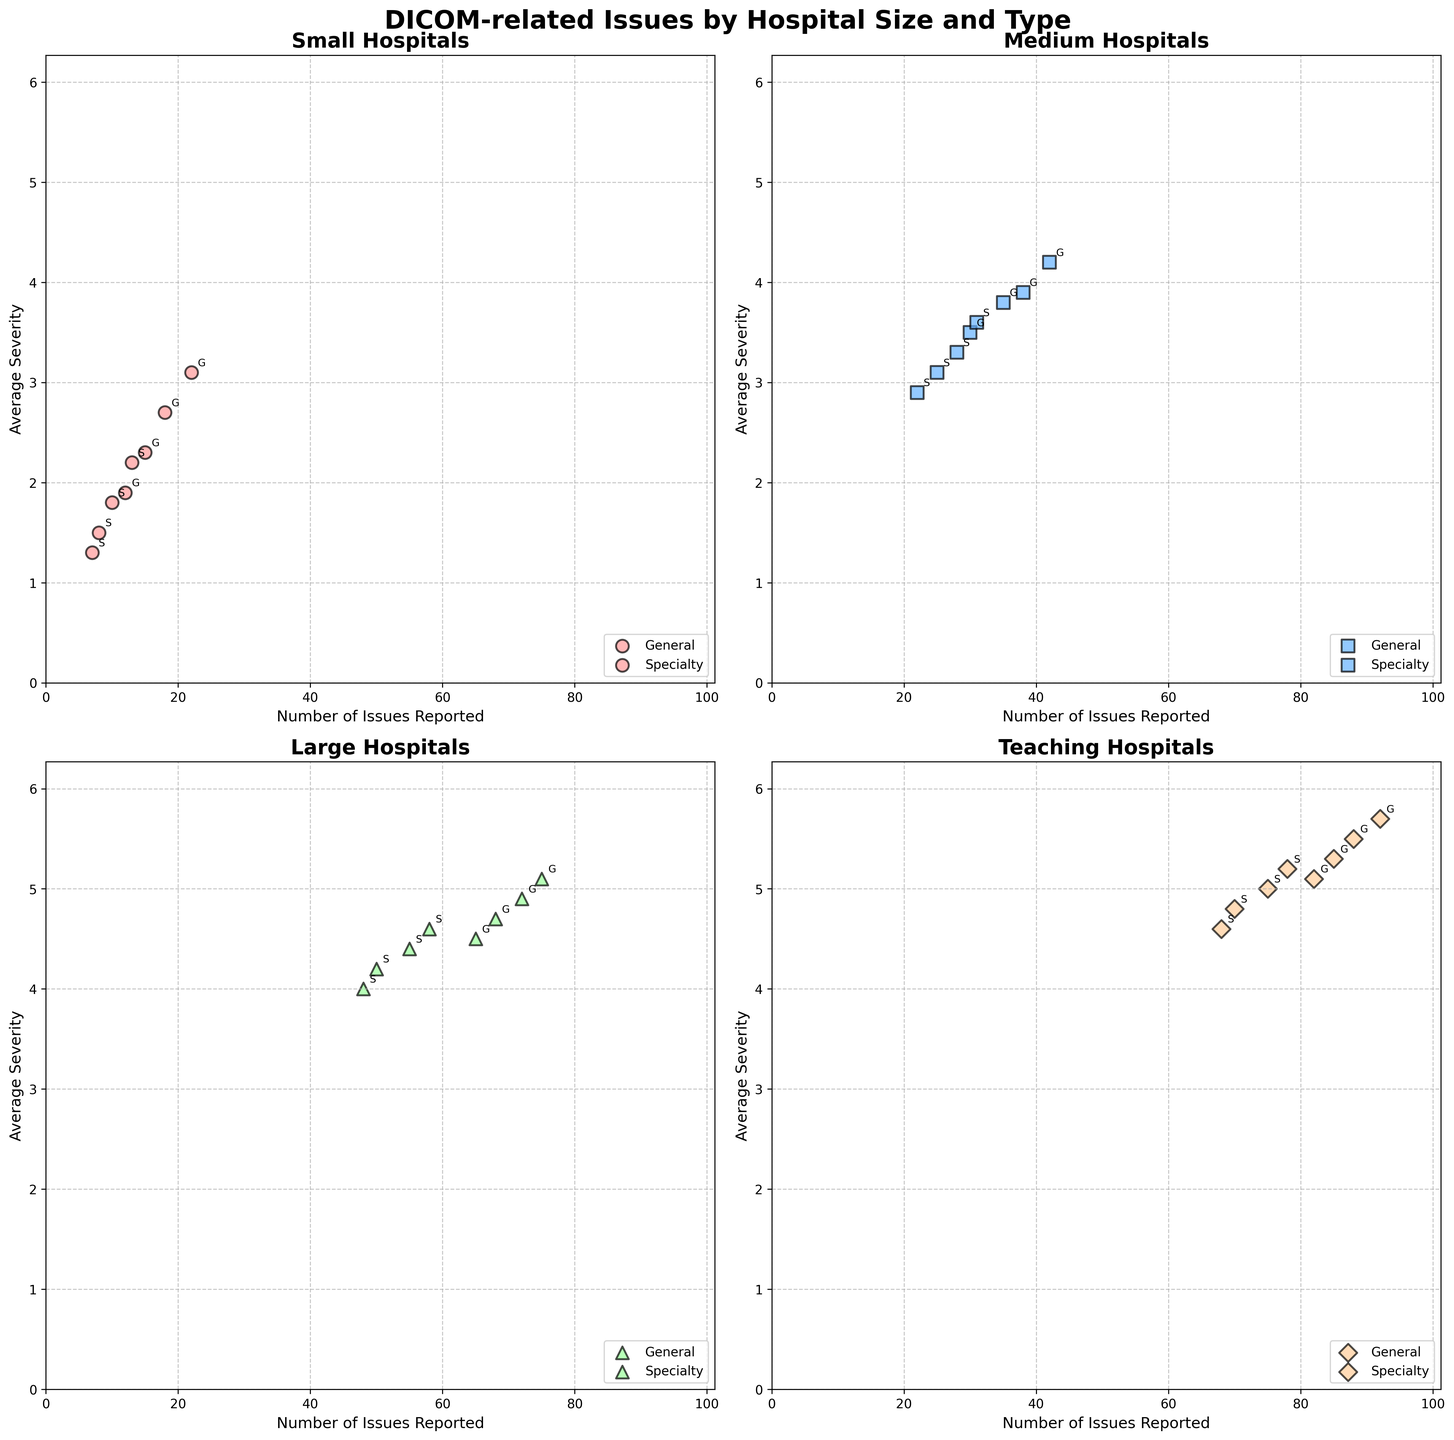What hospital size and type has the highest number of issues reported? The subplot for Teaching hospitals has a point with the highest number of issues reported. It's in the Teaching General category, with the point representing 92 issues reported.
Answer: Teaching General Which type of hospital among Medium hospitals reports a higher average severity of issues, General or Specialty? For Medium hospitals, the subplot shows that the points for General hospitals are higher on the y-axis, indicating that General hospitals have a higher average severity of issues reported compared to Specialty hospitals.
Answer: General What is the average number of issues reported for Large Specialty hospitals, considering the points in the subplot? The number of issues reported for Large Specialty hospitals are 50, 58, 55, and 48. Their average is (50 + 58 + 55 + 48) / 4 = 211 / 4 = 52.75.
Answer: 52.75 Which is the smallest hospital size that has reported an average severity of issues above 4? The subplot for Medium hospitals shows some points above the 4 mark on the y-axis. Since Medium hospitals are the smallest size on the plot to show this, they are the correct answer.
Answer: Medium How does the average severity of issues reported in Large Specialty hospitals compare to Teaching General hospitals? Large Specialty hospitals have an average severity around 4.0 to 4.6, while Teaching General hospitals have an average severity around 5.1 to 5.7. This indicates Teaching General hospitals report higher severity.
Answer: Teaching General What is the trend in the number of issues reported as hospital size increases from Small to Teaching hospitals? The x-axis values (issues reported) increase with hospital size: Small hospitals have fewer issues reported, while Teaching hospitals have more issues reported.
Answer: Increases For Small hospitals, which type generally reports a lower average severity, General or Specialty? In the subplot for Small hospitals, points for Specialty are generally lower on the y-axis compared to General, indicating that Specialty hospitals report a lower average severity.
Answer: Specialty Which hospital type shows the highest variation in the number of issues reported for any given hospital size? Teaching General hospitals' points show a range from 82 to 92 issues reported, indicating the highest variation among the hospital types shown in the subplots.
Answer: Teaching General 